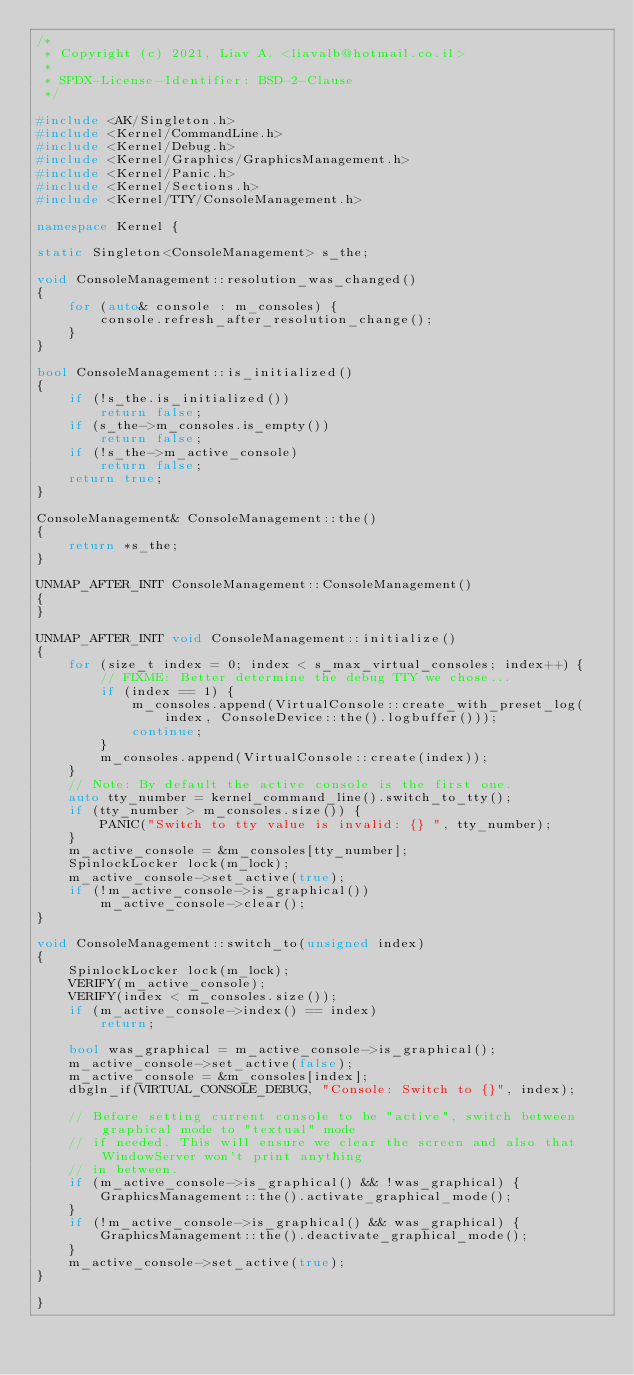<code> <loc_0><loc_0><loc_500><loc_500><_C++_>/*
 * Copyright (c) 2021, Liav A. <liavalb@hotmail.co.il>
 *
 * SPDX-License-Identifier: BSD-2-Clause
 */

#include <AK/Singleton.h>
#include <Kernel/CommandLine.h>
#include <Kernel/Debug.h>
#include <Kernel/Graphics/GraphicsManagement.h>
#include <Kernel/Panic.h>
#include <Kernel/Sections.h>
#include <Kernel/TTY/ConsoleManagement.h>

namespace Kernel {

static Singleton<ConsoleManagement> s_the;

void ConsoleManagement::resolution_was_changed()
{
    for (auto& console : m_consoles) {
        console.refresh_after_resolution_change();
    }
}

bool ConsoleManagement::is_initialized()
{
    if (!s_the.is_initialized())
        return false;
    if (s_the->m_consoles.is_empty())
        return false;
    if (!s_the->m_active_console)
        return false;
    return true;
}

ConsoleManagement& ConsoleManagement::the()
{
    return *s_the;
}

UNMAP_AFTER_INIT ConsoleManagement::ConsoleManagement()
{
}

UNMAP_AFTER_INIT void ConsoleManagement::initialize()
{
    for (size_t index = 0; index < s_max_virtual_consoles; index++) {
        // FIXME: Better determine the debug TTY we chose...
        if (index == 1) {
            m_consoles.append(VirtualConsole::create_with_preset_log(index, ConsoleDevice::the().logbuffer()));
            continue;
        }
        m_consoles.append(VirtualConsole::create(index));
    }
    // Note: By default the active console is the first one.
    auto tty_number = kernel_command_line().switch_to_tty();
    if (tty_number > m_consoles.size()) {
        PANIC("Switch to tty value is invalid: {} ", tty_number);
    }
    m_active_console = &m_consoles[tty_number];
    SpinlockLocker lock(m_lock);
    m_active_console->set_active(true);
    if (!m_active_console->is_graphical())
        m_active_console->clear();
}

void ConsoleManagement::switch_to(unsigned index)
{
    SpinlockLocker lock(m_lock);
    VERIFY(m_active_console);
    VERIFY(index < m_consoles.size());
    if (m_active_console->index() == index)
        return;

    bool was_graphical = m_active_console->is_graphical();
    m_active_console->set_active(false);
    m_active_console = &m_consoles[index];
    dbgln_if(VIRTUAL_CONSOLE_DEBUG, "Console: Switch to {}", index);

    // Before setting current console to be "active", switch between graphical mode to "textual" mode
    // if needed. This will ensure we clear the screen and also that WindowServer won't print anything
    // in between.
    if (m_active_console->is_graphical() && !was_graphical) {
        GraphicsManagement::the().activate_graphical_mode();
    }
    if (!m_active_console->is_graphical() && was_graphical) {
        GraphicsManagement::the().deactivate_graphical_mode();
    }
    m_active_console->set_active(true);
}

}
</code> 